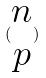Convert formula to latex. <formula><loc_0><loc_0><loc_500><loc_500>( \begin{matrix} n \\ p \end{matrix} )</formula> 